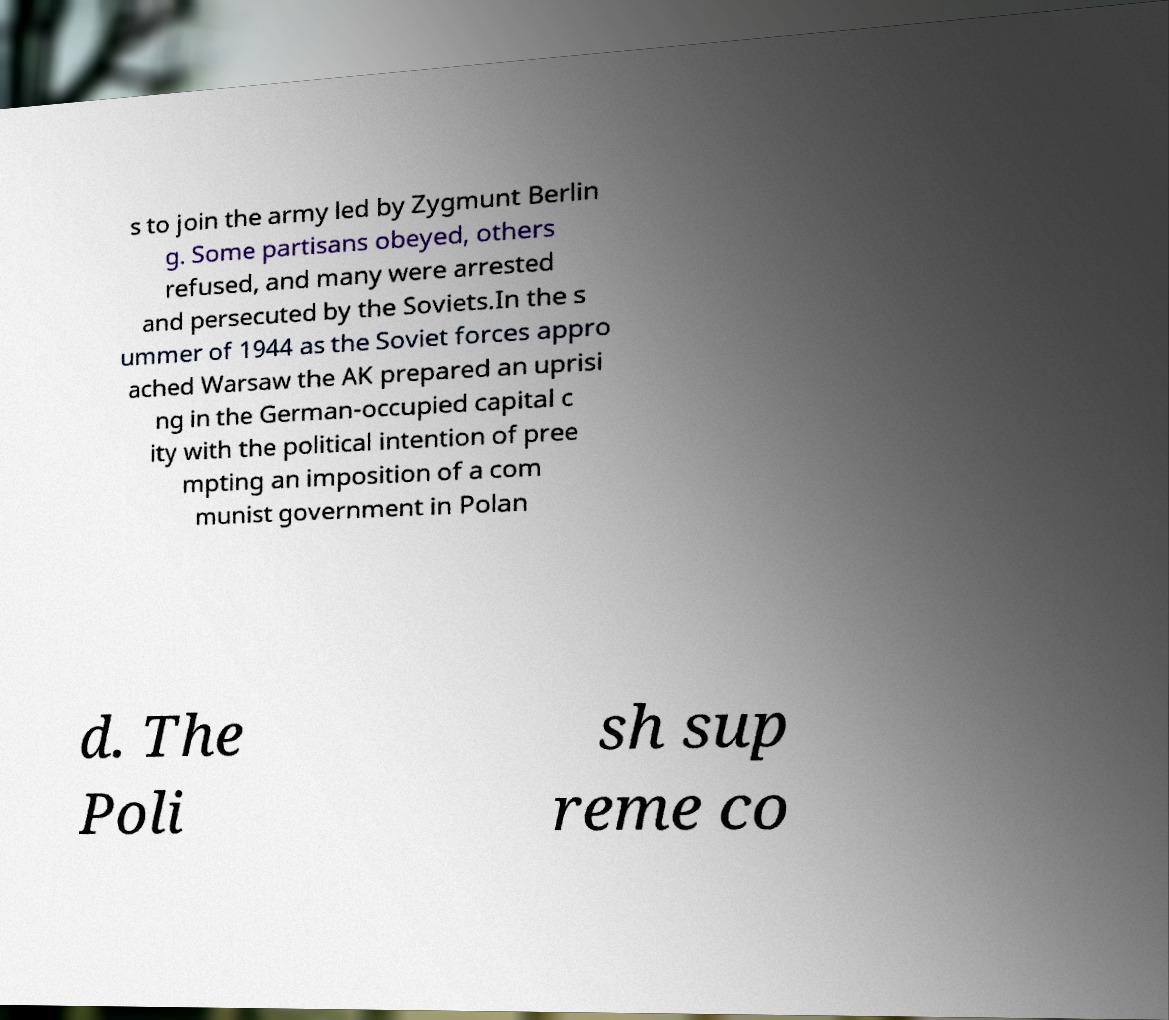Could you assist in decoding the text presented in this image and type it out clearly? s to join the army led by Zygmunt Berlin g. Some partisans obeyed, others refused, and many were arrested and persecuted by the Soviets.In the s ummer of 1944 as the Soviet forces appro ached Warsaw the AK prepared an uprisi ng in the German-occupied capital c ity with the political intention of pree mpting an imposition of a com munist government in Polan d. The Poli sh sup reme co 